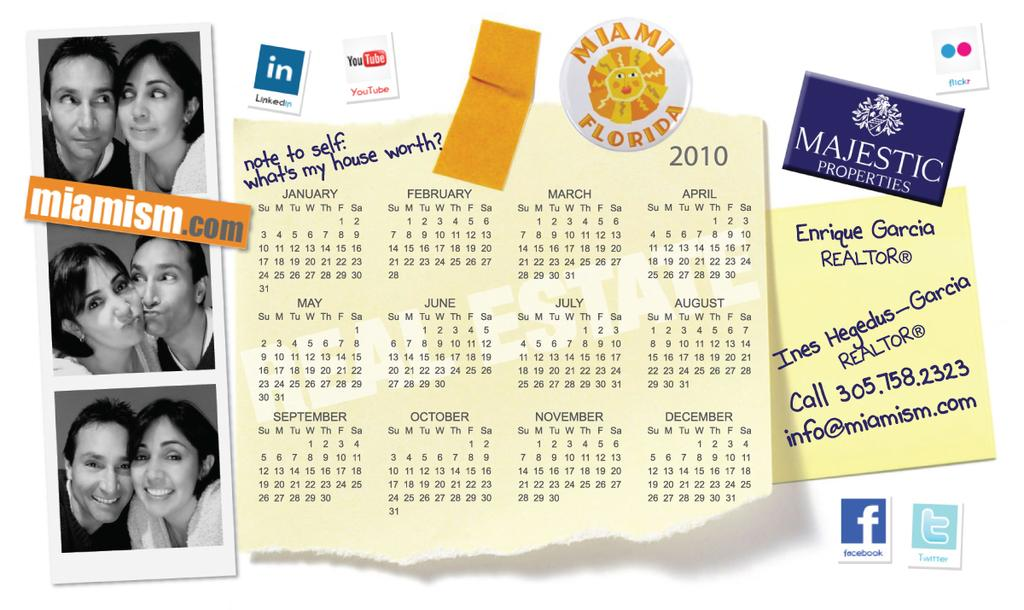What is the main object in the image? There is a photograph in the image. What other items can be seen in the image? There is a calendar and a sticky note in the image. Are there any markings or writings in the image? Yes, there are labelings in the image. What time does dad arrive in the image? There is no mention of a dad or a specific time in the image. 